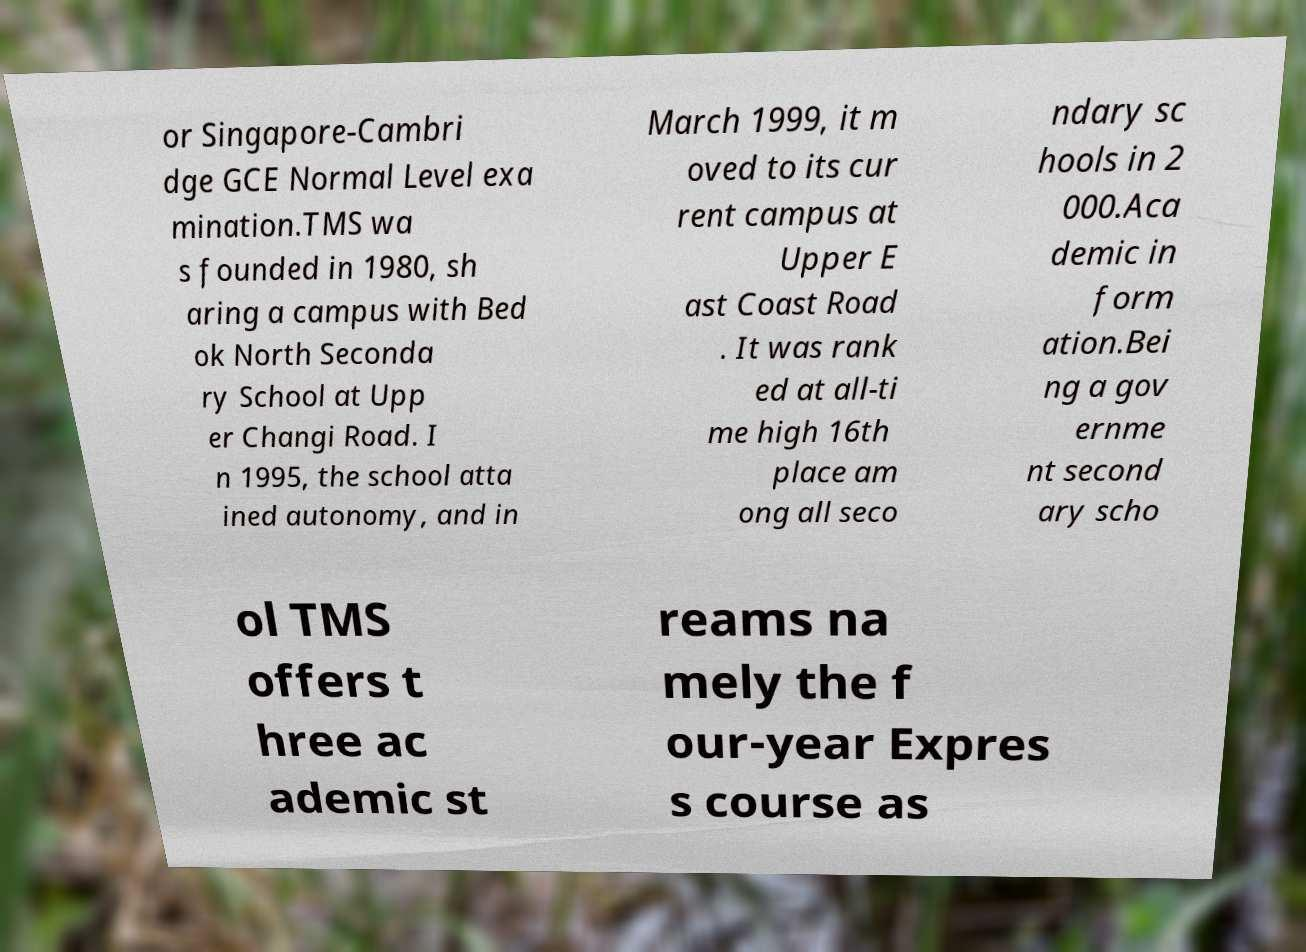Can you read and provide the text displayed in the image?This photo seems to have some interesting text. Can you extract and type it out for me? or Singapore-Cambri dge GCE Normal Level exa mination.TMS wa s founded in 1980, sh aring a campus with Bed ok North Seconda ry School at Upp er Changi Road. I n 1995, the school atta ined autonomy, and in March 1999, it m oved to its cur rent campus at Upper E ast Coast Road . It was rank ed at all-ti me high 16th place am ong all seco ndary sc hools in 2 000.Aca demic in form ation.Bei ng a gov ernme nt second ary scho ol TMS offers t hree ac ademic st reams na mely the f our-year Expres s course as 